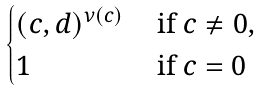Convert formula to latex. <formula><loc_0><loc_0><loc_500><loc_500>\begin{cases} ( c , d ) ^ { \nu ( c ) } & \text { if } c \neq 0 , \\ 1 & \text { if } c = 0 \end{cases}</formula> 